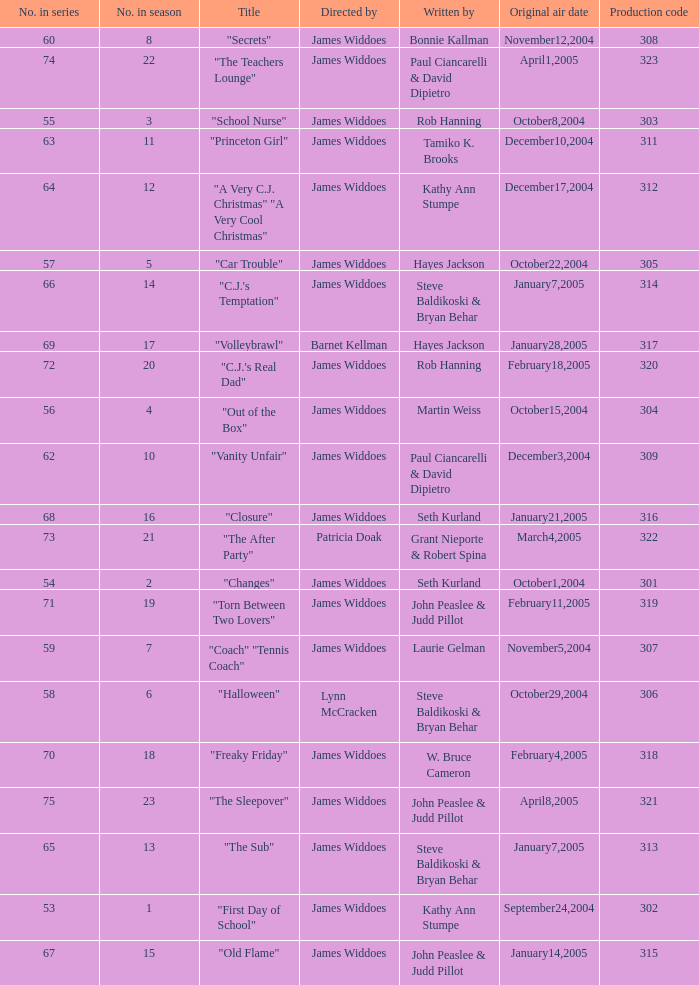What is the production code for episode 3 of the season? 303.0. 